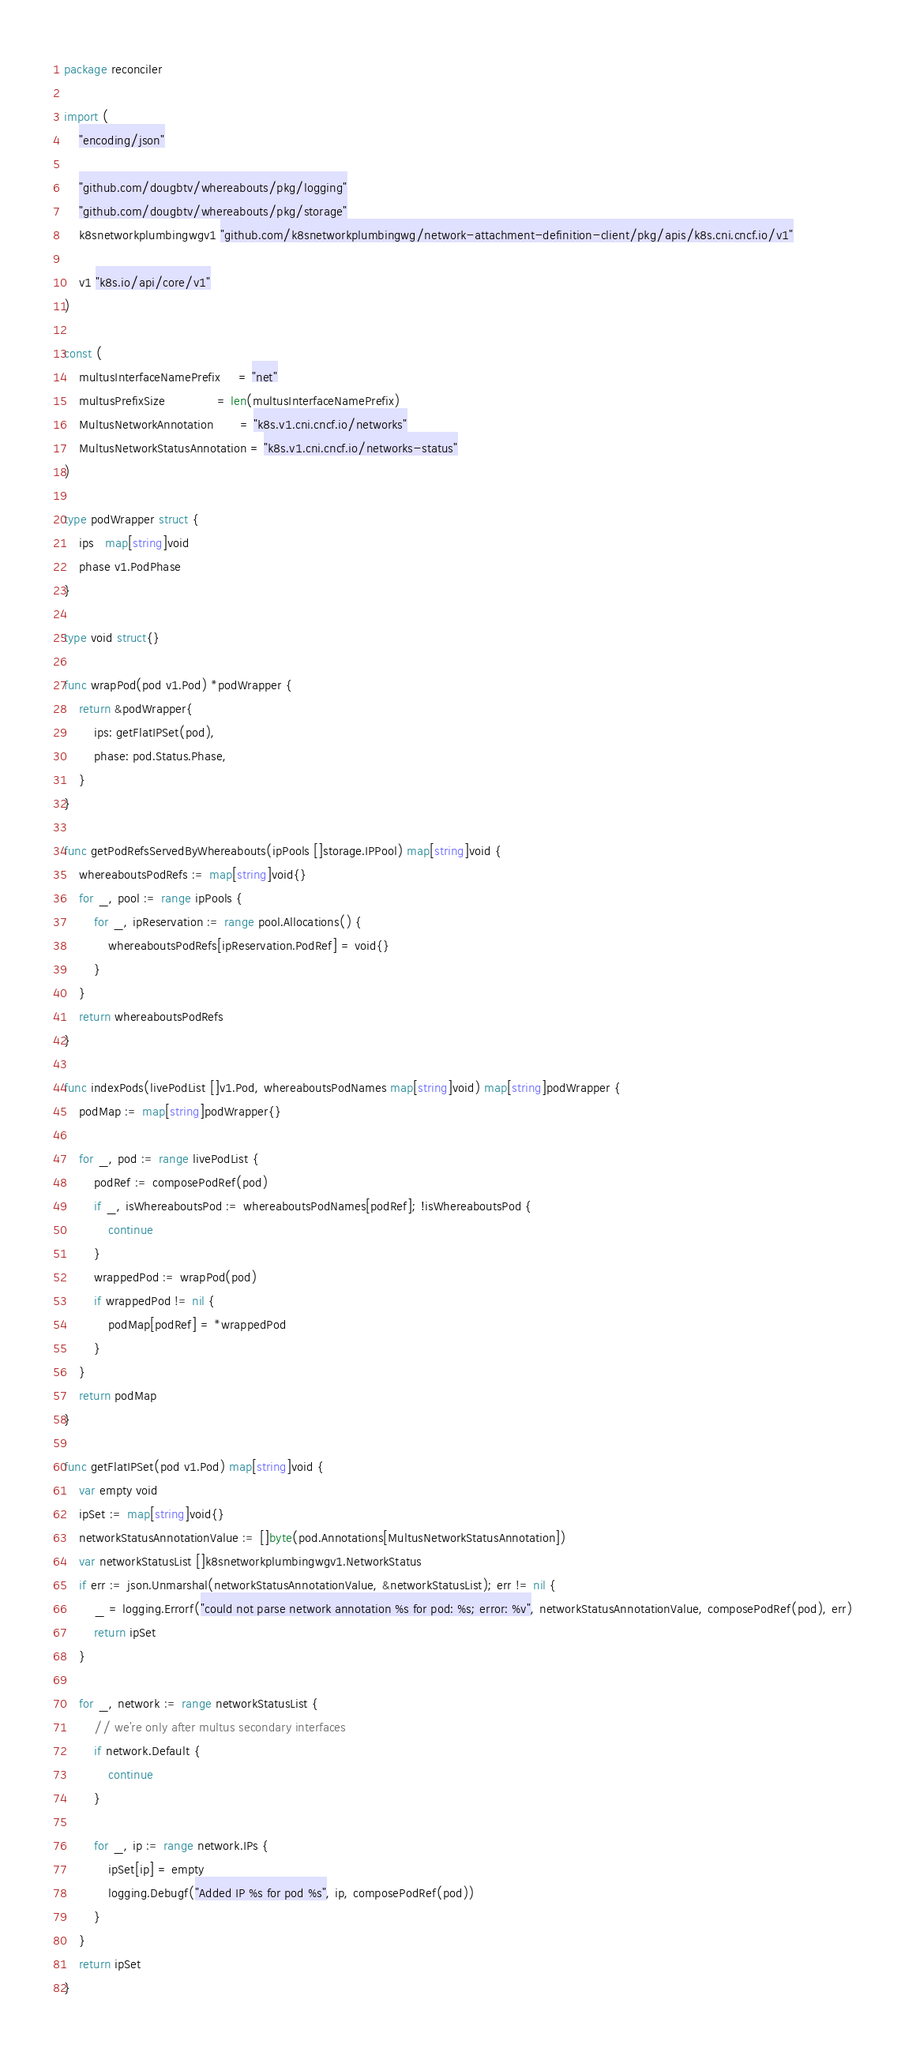Convert code to text. <code><loc_0><loc_0><loc_500><loc_500><_Go_>package reconciler

import (
	"encoding/json"

	"github.com/dougbtv/whereabouts/pkg/logging"
	"github.com/dougbtv/whereabouts/pkg/storage"
	k8snetworkplumbingwgv1 "github.com/k8snetworkplumbingwg/network-attachment-definition-client/pkg/apis/k8s.cni.cncf.io/v1"

	v1 "k8s.io/api/core/v1"
)

const (
	multusInterfaceNamePrefix     = "net"
	multusPrefixSize              = len(multusInterfaceNamePrefix)
	MultusNetworkAnnotation       = "k8s.v1.cni.cncf.io/networks"
	MultusNetworkStatusAnnotation = "k8s.v1.cni.cncf.io/networks-status"
)

type podWrapper struct {
	ips   map[string]void
	phase v1.PodPhase
}

type void struct{}

func wrapPod(pod v1.Pod) *podWrapper {
	return &podWrapper{
		ips: getFlatIPSet(pod),
		phase: pod.Status.Phase,
	}
}

func getPodRefsServedByWhereabouts(ipPools []storage.IPPool) map[string]void {
	whereaboutsPodRefs := map[string]void{}
	for _, pool := range ipPools {
		for _, ipReservation := range pool.Allocations() {
			whereaboutsPodRefs[ipReservation.PodRef] = void{}
		}
	}
	return whereaboutsPodRefs
}

func indexPods(livePodList []v1.Pod, whereaboutsPodNames map[string]void) map[string]podWrapper {
	podMap := map[string]podWrapper{}

	for _, pod := range livePodList {
		podRef := composePodRef(pod)
		if _, isWhereaboutsPod := whereaboutsPodNames[podRef]; !isWhereaboutsPod {
			continue
		}
		wrappedPod := wrapPod(pod)
		if wrappedPod != nil {
			podMap[podRef] = *wrappedPod
		}
	}
	return podMap
}

func getFlatIPSet(pod v1.Pod) map[string]void {
	var empty void
	ipSet := map[string]void{}
	networkStatusAnnotationValue := []byte(pod.Annotations[MultusNetworkStatusAnnotation])
	var networkStatusList []k8snetworkplumbingwgv1.NetworkStatus
	if err := json.Unmarshal(networkStatusAnnotationValue, &networkStatusList); err != nil {
		_ = logging.Errorf("could not parse network annotation %s for pod: %s; error: %v", networkStatusAnnotationValue, composePodRef(pod), err)
		return ipSet
	}

	for _, network := range networkStatusList {
		// we're only after multus secondary interfaces
		if network.Default {
			continue
		}

		for _, ip := range network.IPs {
			ipSet[ip] = empty
            logging.Debugf("Added IP %s for pod %s", ip, composePodRef(pod))
		}
	}
	return ipSet
}
</code> 